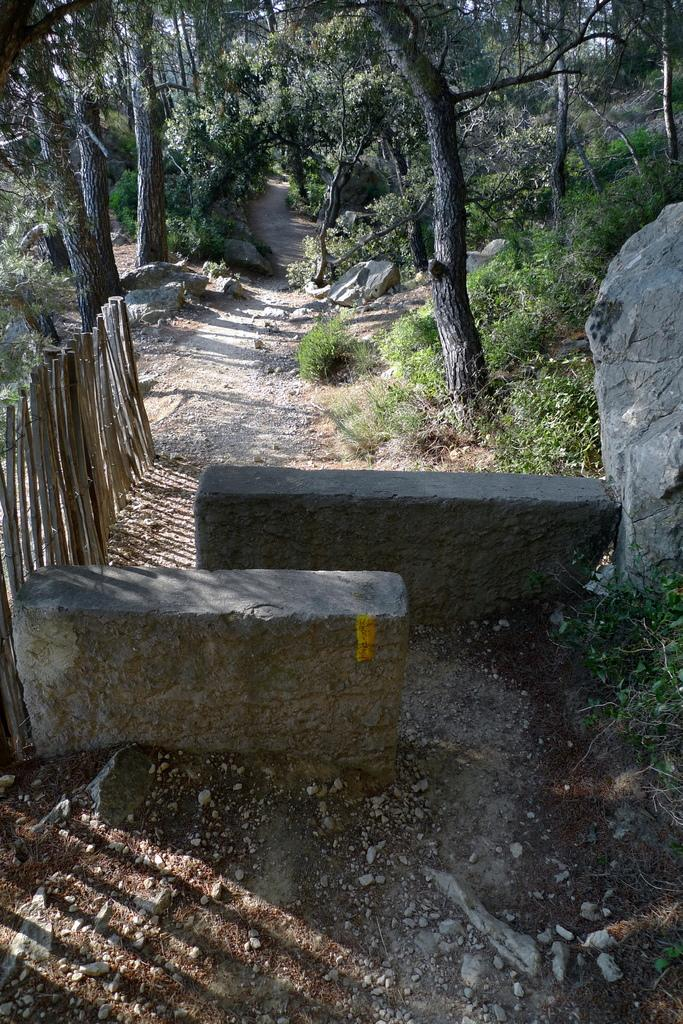What can be seen in the foreground of the picture? In the foreground of the picture, there are stones, plants, and a railing. There is also soil present. What is visible in the background of the picture? In the background of the picture, there are trees, stones, shrubs, and plants. Can you describe the vegetation in the picture? The picture features plants in both the foreground and background, as well as trees and shrubs in the background. How many cats are sitting on the stones in the background of the image? There are no cats present in the image. What type of ant can be seen crawling on the railing in the foreground of the image? There are no ants visible in the image, and therefore no such activity can be observed. 